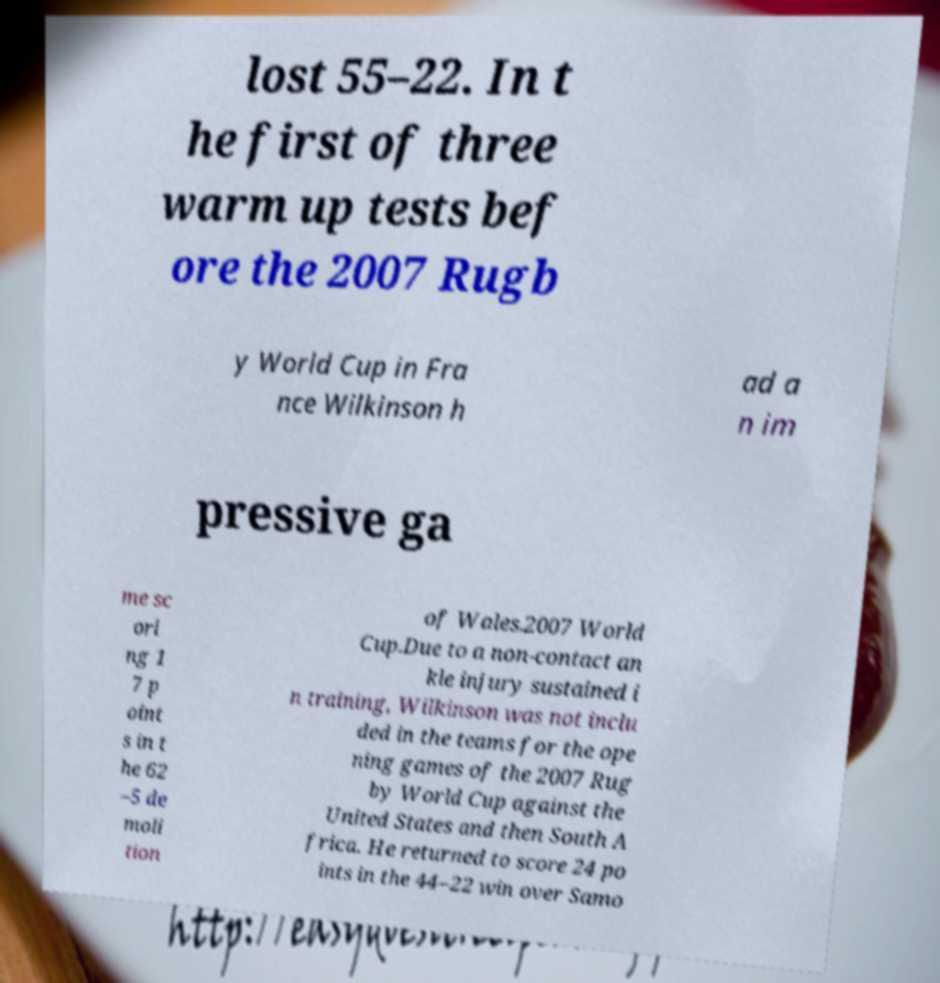Could you extract and type out the text from this image? lost 55–22. In t he first of three warm up tests bef ore the 2007 Rugb y World Cup in Fra nce Wilkinson h ad a n im pressive ga me sc ori ng 1 7 p oint s in t he 62 –5 de moli tion of Wales.2007 World Cup.Due to a non-contact an kle injury sustained i n training, Wilkinson was not inclu ded in the teams for the ope ning games of the 2007 Rug by World Cup against the United States and then South A frica. He returned to score 24 po ints in the 44–22 win over Samo 